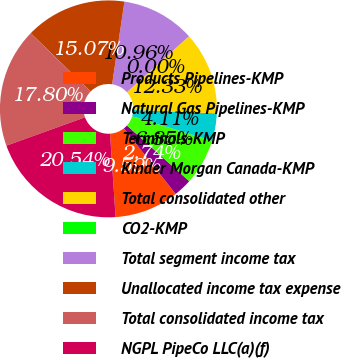<chart> <loc_0><loc_0><loc_500><loc_500><pie_chart><fcel>Products Pipelines-KMP<fcel>Natural Gas Pipelines-KMP<fcel>Terminals-KMP<fcel>Kinder Morgan Canada-KMP<fcel>Total consolidated other<fcel>CO2-KMP<fcel>Total segment income tax<fcel>Unallocated income tax expense<fcel>Total consolidated income tax<fcel>NGPL PipeCo LLC(a)(f)<nl><fcel>9.59%<fcel>2.74%<fcel>6.85%<fcel>4.11%<fcel>12.33%<fcel>0.0%<fcel>10.96%<fcel>15.07%<fcel>17.8%<fcel>20.54%<nl></chart> 